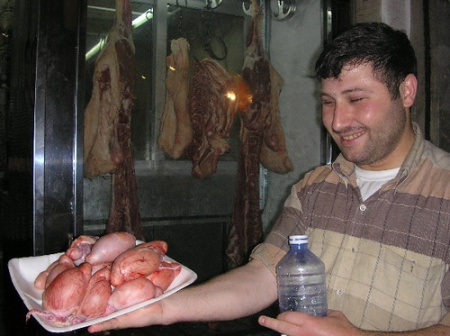Can you tell more about the types of meat displayed and their culinary uses? The image showcases several types of meat. The man is holding a plate with raw meats resembling pink cuts of possibly chicken or pork, commonly used in a variety of dishes from stews to grilled preparations. The hanging meats in the background include darker, possibly smoked or cured pieces, likely beef or pork, used for flavor-rich dishes like charcuterie boards, sandwiches, or as part of traditional cooking methods in many cultures. These meats are often prized for their depth of flavor and preservation qualities. 